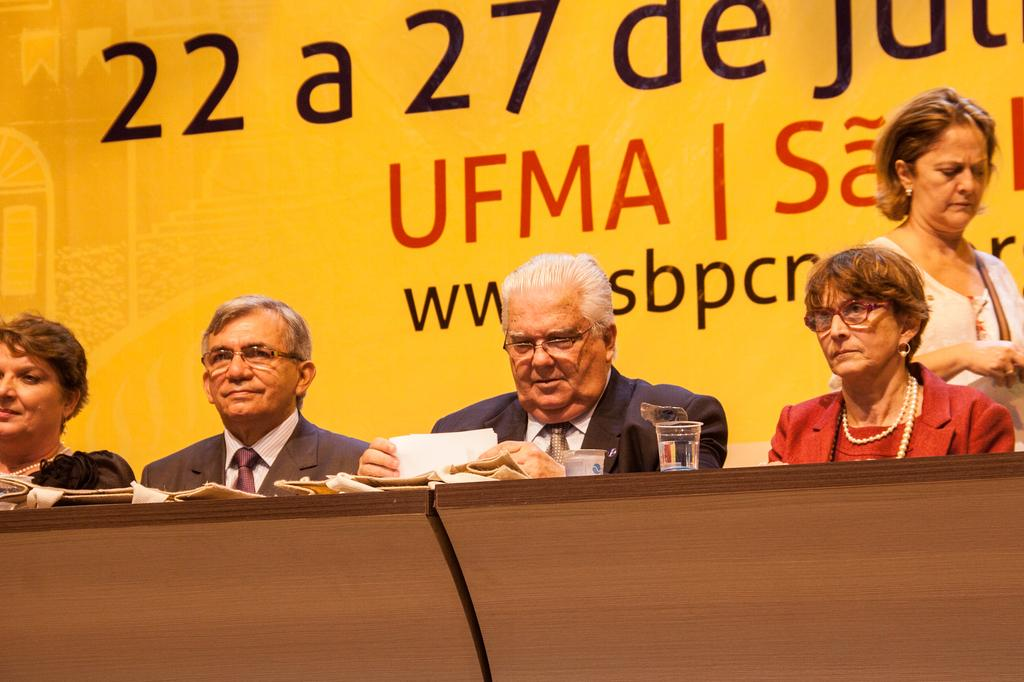Who or what is present in the image? There are people in the image. What material is visible in the image? There is glass in the image. What type of object can be seen in the image? There are papers in the image. What is the wooden object in the image used for? The wooden object in the image is not specified, but it is likely a piece of furniture or a decorative item. What can be seen on the poster in the background of the image? There is a poster with text in the background of the image. How many girls are playing with the pump in the image? There is no pump or girls present in the image. What type of skin is visible on the people in the image? The image does not provide enough detail to determine the type of skin visible on the people. 